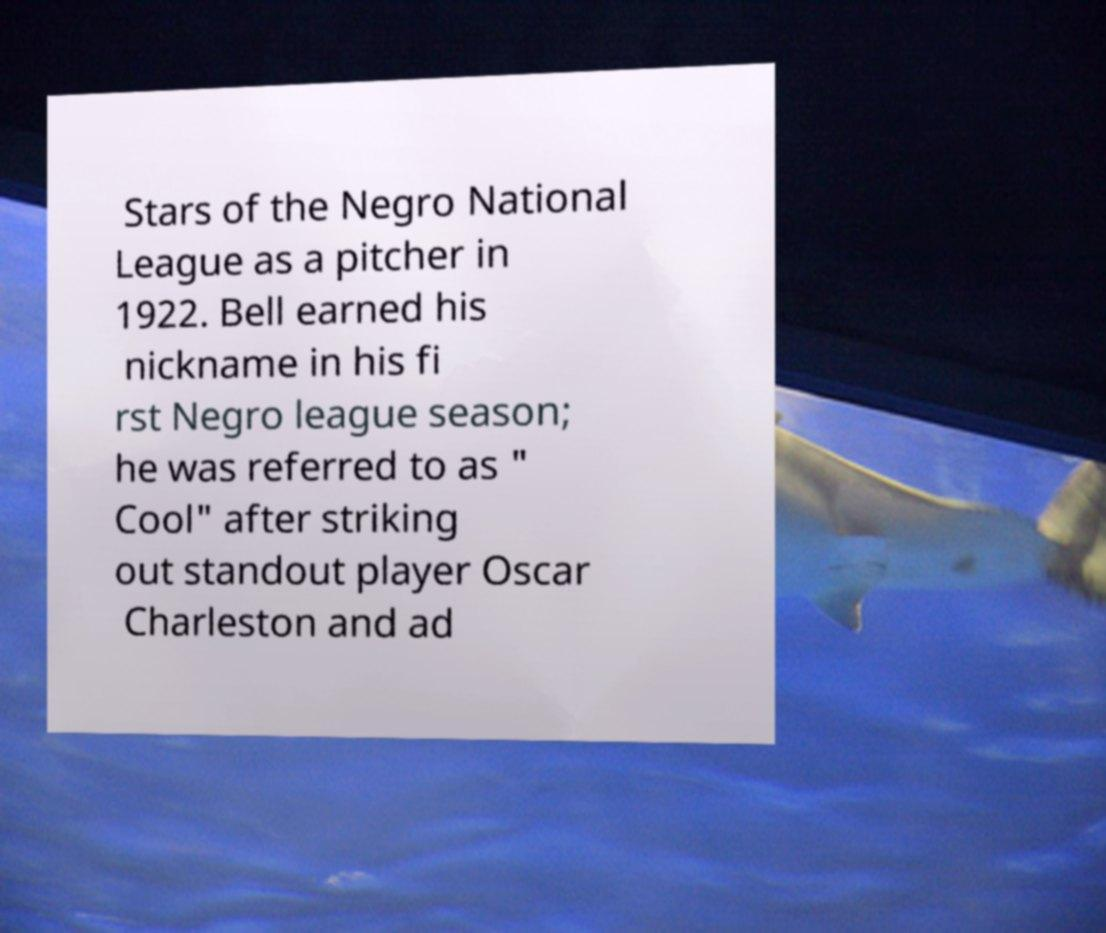Please read and relay the text visible in this image. What does it say? Stars of the Negro National League as a pitcher in 1922. Bell earned his nickname in his fi rst Negro league season; he was referred to as " Cool" after striking out standout player Oscar Charleston and ad 